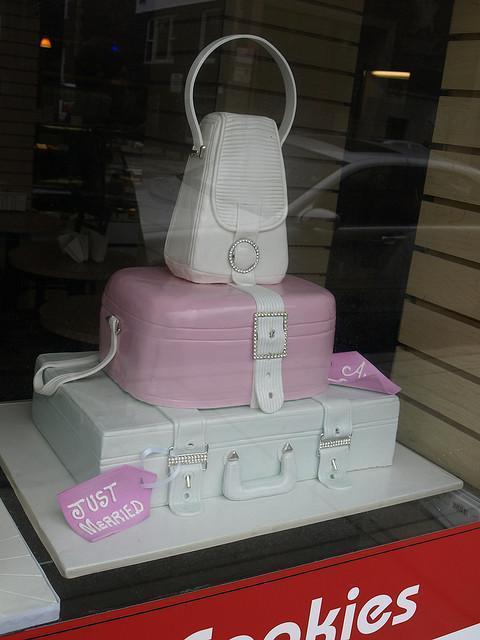How many colors are the three pieces of luggage?
Give a very brief answer. 2. How many dolls are on this cake?
Give a very brief answer. 0. How many suitcases can you see?
Give a very brief answer. 2. 